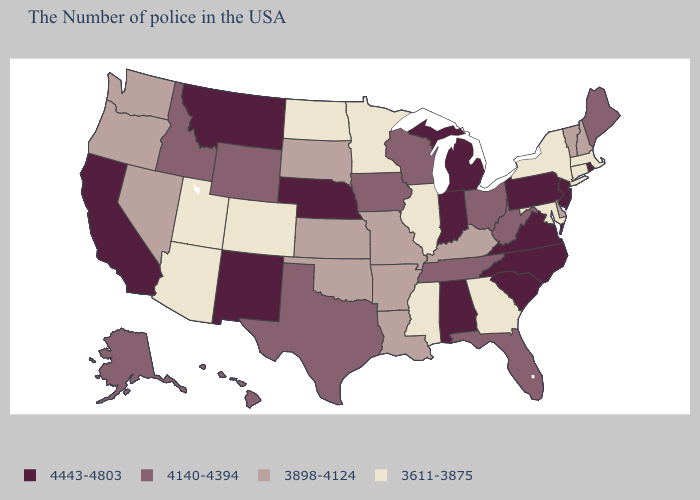Does the first symbol in the legend represent the smallest category?
Short answer required. No. Among the states that border Florida , does Alabama have the lowest value?
Concise answer only. No. What is the highest value in states that border New Hampshire?
Quick response, please. 4140-4394. What is the value of New Jersey?
Quick response, please. 4443-4803. Does Maryland have the lowest value in the USA?
Be succinct. Yes. Among the states that border Mississippi , which have the lowest value?
Answer briefly. Louisiana, Arkansas. What is the value of Utah?
Write a very short answer. 3611-3875. Does Hawaii have a lower value than Rhode Island?
Answer briefly. Yes. What is the value of Delaware?
Concise answer only. 3898-4124. Does Nebraska have the highest value in the USA?
Concise answer only. Yes. What is the highest value in the MidWest ?
Concise answer only. 4443-4803. What is the highest value in the USA?
Short answer required. 4443-4803. Among the states that border Kansas , which have the lowest value?
Short answer required. Colorado. Which states have the lowest value in the South?
Keep it brief. Maryland, Georgia, Mississippi. What is the value of West Virginia?
Answer briefly. 4140-4394. 